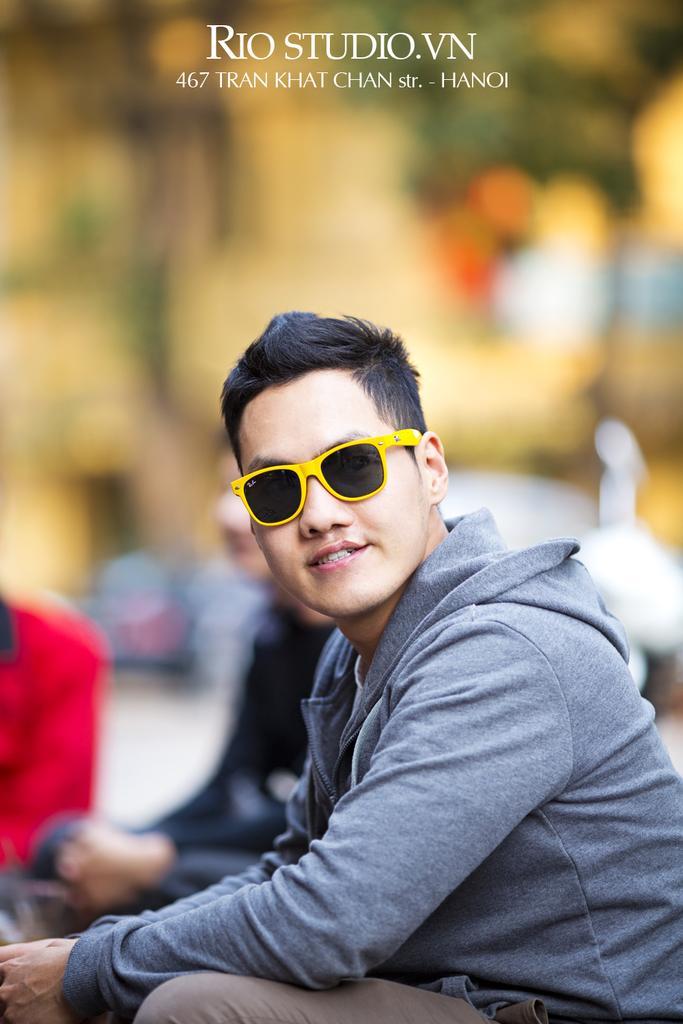Could you give a brief overview of what you see in this image? In this image, we can see a person wearing clothes and sunglasses. There is a text at the top of the image. In the background, image is blurred. 